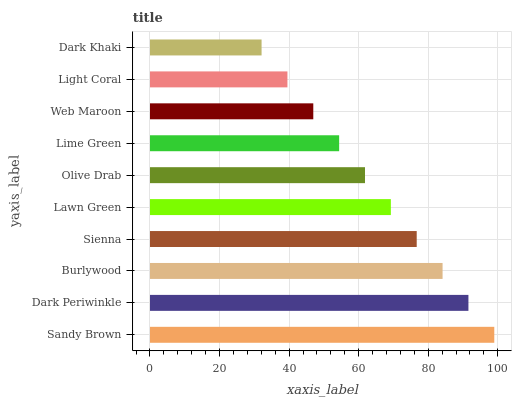Is Dark Khaki the minimum?
Answer yes or no. Yes. Is Sandy Brown the maximum?
Answer yes or no. Yes. Is Dark Periwinkle the minimum?
Answer yes or no. No. Is Dark Periwinkle the maximum?
Answer yes or no. No. Is Sandy Brown greater than Dark Periwinkle?
Answer yes or no. Yes. Is Dark Periwinkle less than Sandy Brown?
Answer yes or no. Yes. Is Dark Periwinkle greater than Sandy Brown?
Answer yes or no. No. Is Sandy Brown less than Dark Periwinkle?
Answer yes or no. No. Is Lawn Green the high median?
Answer yes or no. Yes. Is Olive Drab the low median?
Answer yes or no. Yes. Is Olive Drab the high median?
Answer yes or no. No. Is Lawn Green the low median?
Answer yes or no. No. 